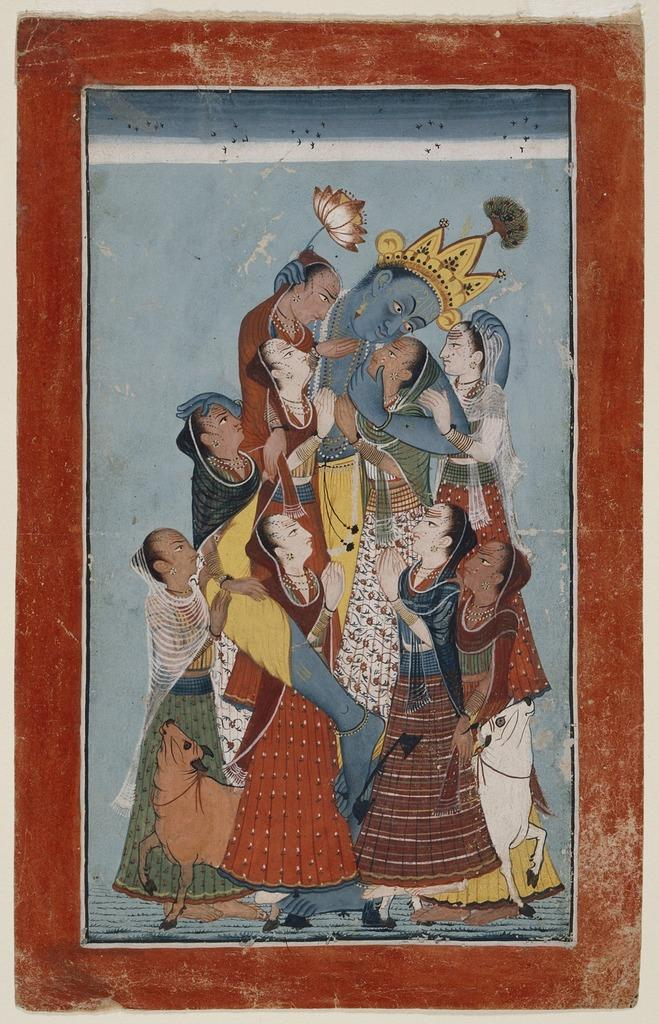What object is present in the image that typically holds a visual representation? There is a photo frame in the image. What is displayed within the photo frame? The photo frame contains a painting. What is the subject matter of the painting? The painting depicts many people. Can you describe the person in the center of the painting? The person in the center of the painting is wearing a crown and holding a lotus. Are there any animals present in the painting? Yes, there are 2 animals at the bottom of the painting. What type of lace is being used to create a drum in the image? There is no drum or lace present in the image. 